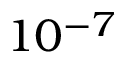<formula> <loc_0><loc_0><loc_500><loc_500>1 0 ^ { - 7 }</formula> 